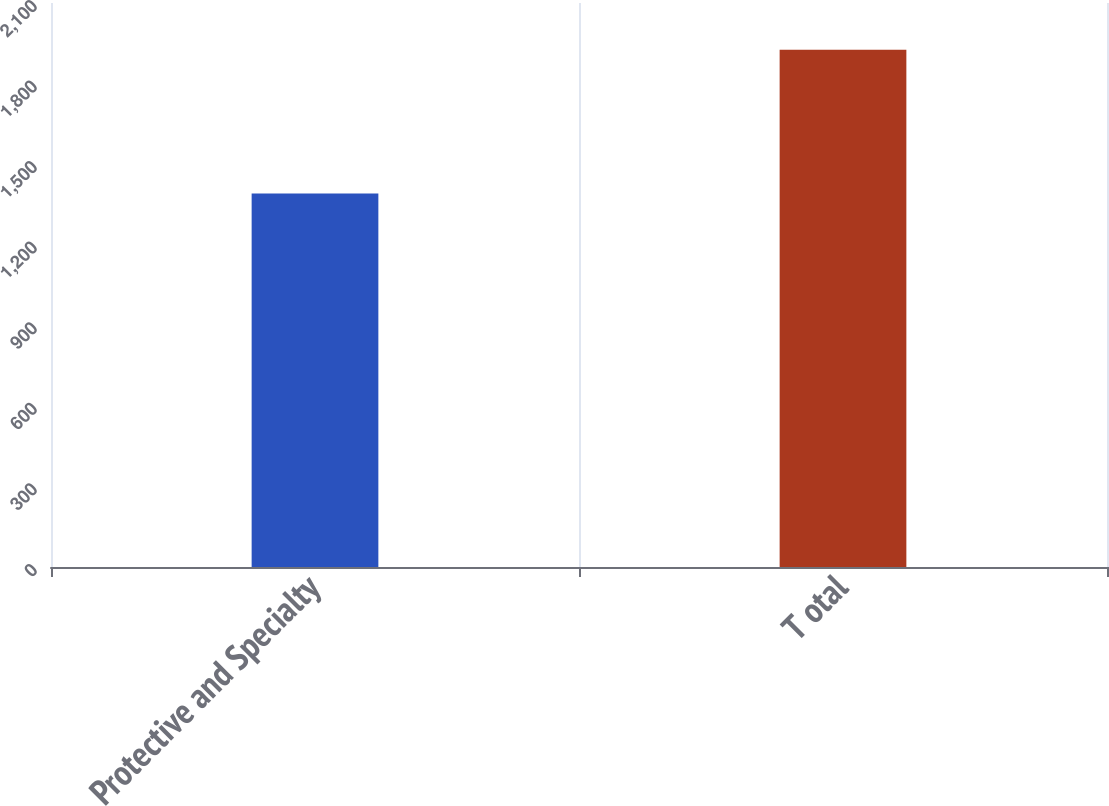<chart> <loc_0><loc_0><loc_500><loc_500><bar_chart><fcel>Protective and Specialty<fcel>T otal<nl><fcel>1390.9<fcel>1926.2<nl></chart> 